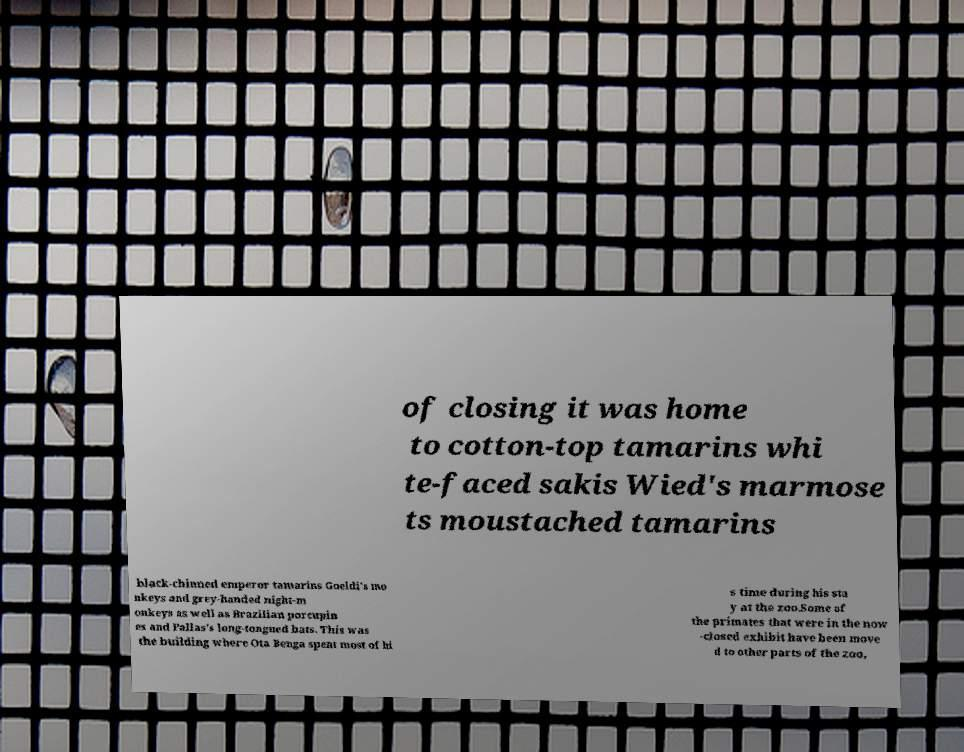For documentation purposes, I need the text within this image transcribed. Could you provide that? of closing it was home to cotton-top tamarins whi te-faced sakis Wied's marmose ts moustached tamarins black-chinned emperor tamarins Goeldi's mo nkeys and grey-handed night-m onkeys as well as Brazilian porcupin es and Pallas's long-tongued bats. This was the building where Ota Benga spent most of hi s time during his sta y at the zoo.Some of the primates that were in the now -closed exhibit have been move d to other parts of the zoo, 